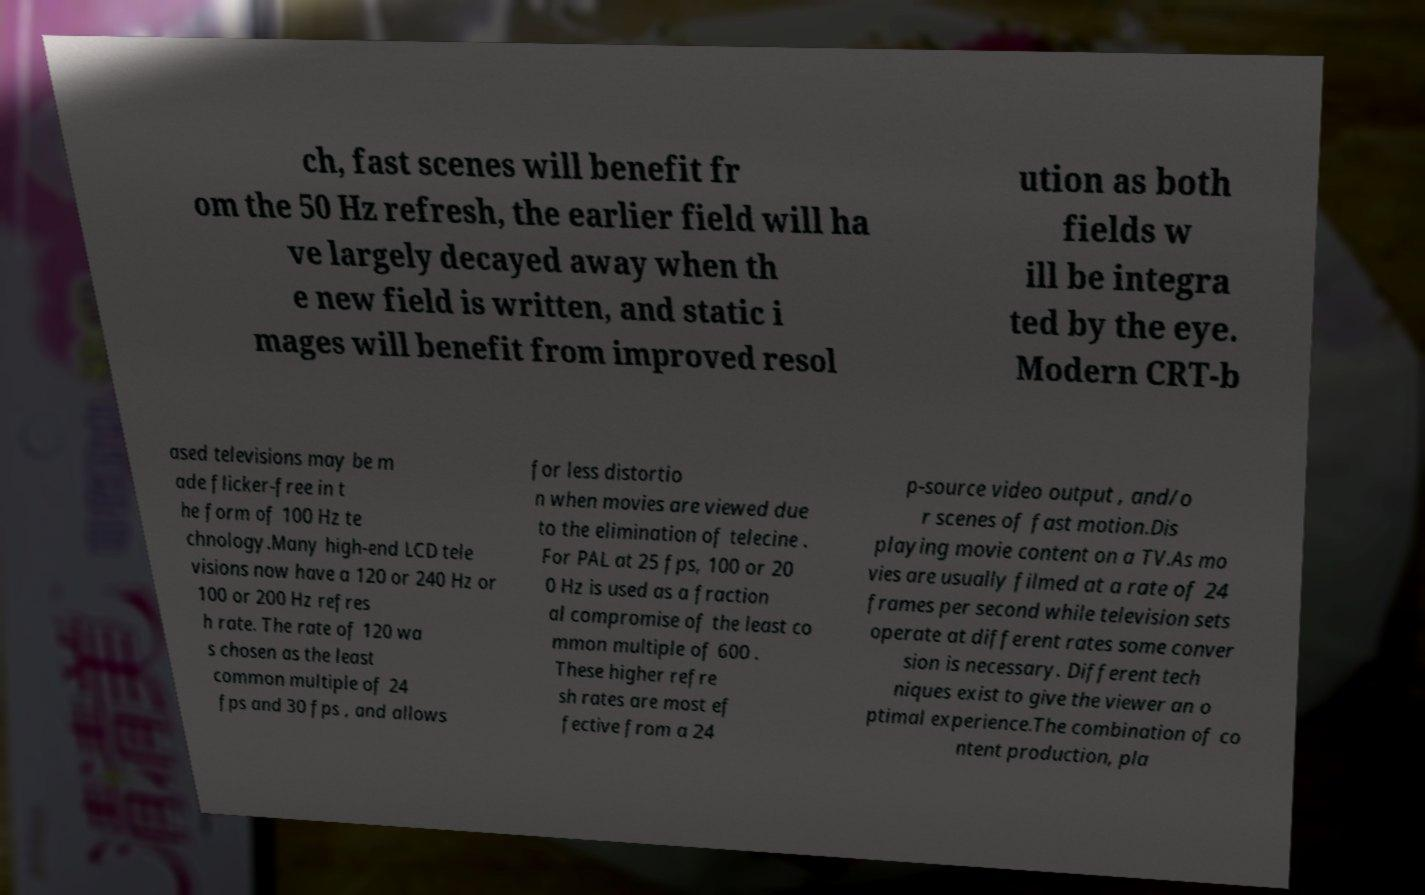Please identify and transcribe the text found in this image. ch, fast scenes will benefit fr om the 50 Hz refresh, the earlier field will ha ve largely decayed away when th e new field is written, and static i mages will benefit from improved resol ution as both fields w ill be integra ted by the eye. Modern CRT-b ased televisions may be m ade flicker-free in t he form of 100 Hz te chnology.Many high-end LCD tele visions now have a 120 or 240 Hz or 100 or 200 Hz refres h rate. The rate of 120 wa s chosen as the least common multiple of 24 fps and 30 fps , and allows for less distortio n when movies are viewed due to the elimination of telecine . For PAL at 25 fps, 100 or 20 0 Hz is used as a fraction al compromise of the least co mmon multiple of 600 . These higher refre sh rates are most ef fective from a 24 p-source video output , and/o r scenes of fast motion.Dis playing movie content on a TV.As mo vies are usually filmed at a rate of 24 frames per second while television sets operate at different rates some conver sion is necessary. Different tech niques exist to give the viewer an o ptimal experience.The combination of co ntent production, pla 